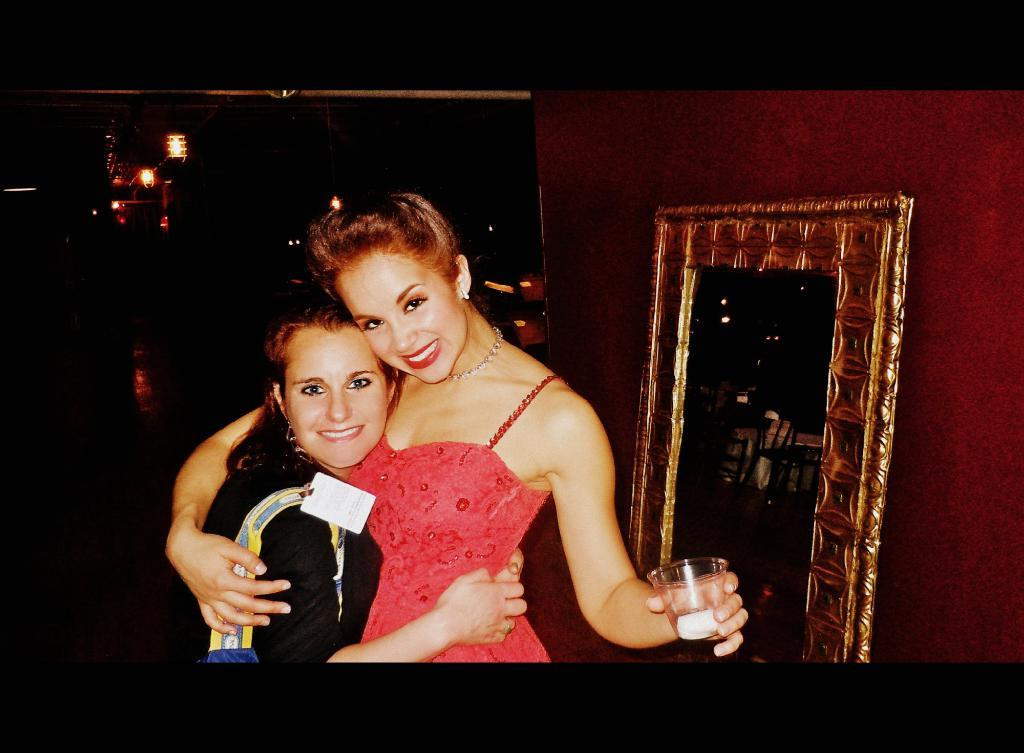How many people are in the image? There are two girls in the image. What are the girls doing in the image? The girls are standing in front and posing for the camera. What can be seen behind the girls in the image? There is a dark background in the image. What is located on the right side of the image? There is a glass mirror and a wall on the right side of the image. What type of fruit is hanging from the yoke in the image? There is no yoke or fruit present in the image. 